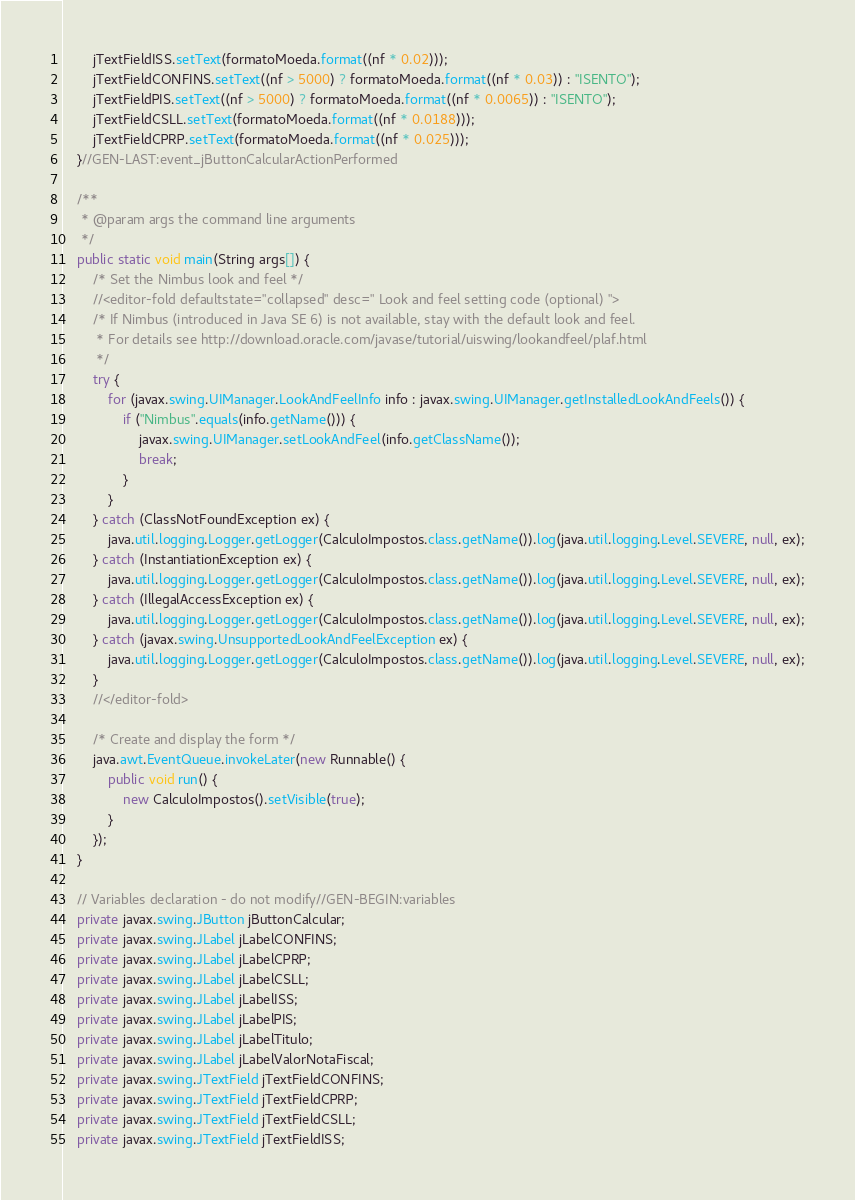Convert code to text. <code><loc_0><loc_0><loc_500><loc_500><_Java_>        jTextFieldISS.setText(formatoMoeda.format((nf * 0.02)));
        jTextFieldCONFINS.setText((nf > 5000) ? formatoMoeda.format((nf * 0.03)) : "ISENTO");
        jTextFieldPIS.setText((nf > 5000) ? formatoMoeda.format((nf * 0.0065)) : "ISENTO");
        jTextFieldCSLL.setText(formatoMoeda.format((nf * 0.0188)));
        jTextFieldCPRP.setText(formatoMoeda.format((nf * 0.025)));
    }//GEN-LAST:event_jButtonCalcularActionPerformed

    /**
     * @param args the command line arguments
     */
    public static void main(String args[]) {
        /* Set the Nimbus look and feel */
        //<editor-fold defaultstate="collapsed" desc=" Look and feel setting code (optional) ">
        /* If Nimbus (introduced in Java SE 6) is not available, stay with the default look and feel.
         * For details see http://download.oracle.com/javase/tutorial/uiswing/lookandfeel/plaf.html 
         */
        try {
            for (javax.swing.UIManager.LookAndFeelInfo info : javax.swing.UIManager.getInstalledLookAndFeels()) {
                if ("Nimbus".equals(info.getName())) {
                    javax.swing.UIManager.setLookAndFeel(info.getClassName());
                    break;
                }
            }
        } catch (ClassNotFoundException ex) {
            java.util.logging.Logger.getLogger(CalculoImpostos.class.getName()).log(java.util.logging.Level.SEVERE, null, ex);
        } catch (InstantiationException ex) {
            java.util.logging.Logger.getLogger(CalculoImpostos.class.getName()).log(java.util.logging.Level.SEVERE, null, ex);
        } catch (IllegalAccessException ex) {
            java.util.logging.Logger.getLogger(CalculoImpostos.class.getName()).log(java.util.logging.Level.SEVERE, null, ex);
        } catch (javax.swing.UnsupportedLookAndFeelException ex) {
            java.util.logging.Logger.getLogger(CalculoImpostos.class.getName()).log(java.util.logging.Level.SEVERE, null, ex);
        }
        //</editor-fold>

        /* Create and display the form */
        java.awt.EventQueue.invokeLater(new Runnable() {
            public void run() {
                new CalculoImpostos().setVisible(true);
            }
        });
    }

    // Variables declaration - do not modify//GEN-BEGIN:variables
    private javax.swing.JButton jButtonCalcular;
    private javax.swing.JLabel jLabelCONFINS;
    private javax.swing.JLabel jLabelCPRP;
    private javax.swing.JLabel jLabelCSLL;
    private javax.swing.JLabel jLabelISS;
    private javax.swing.JLabel jLabelPIS;
    private javax.swing.JLabel jLabelTitulo;
    private javax.swing.JLabel jLabelValorNotaFiscal;
    private javax.swing.JTextField jTextFieldCONFINS;
    private javax.swing.JTextField jTextFieldCPRP;
    private javax.swing.JTextField jTextFieldCSLL;
    private javax.swing.JTextField jTextFieldISS;</code> 